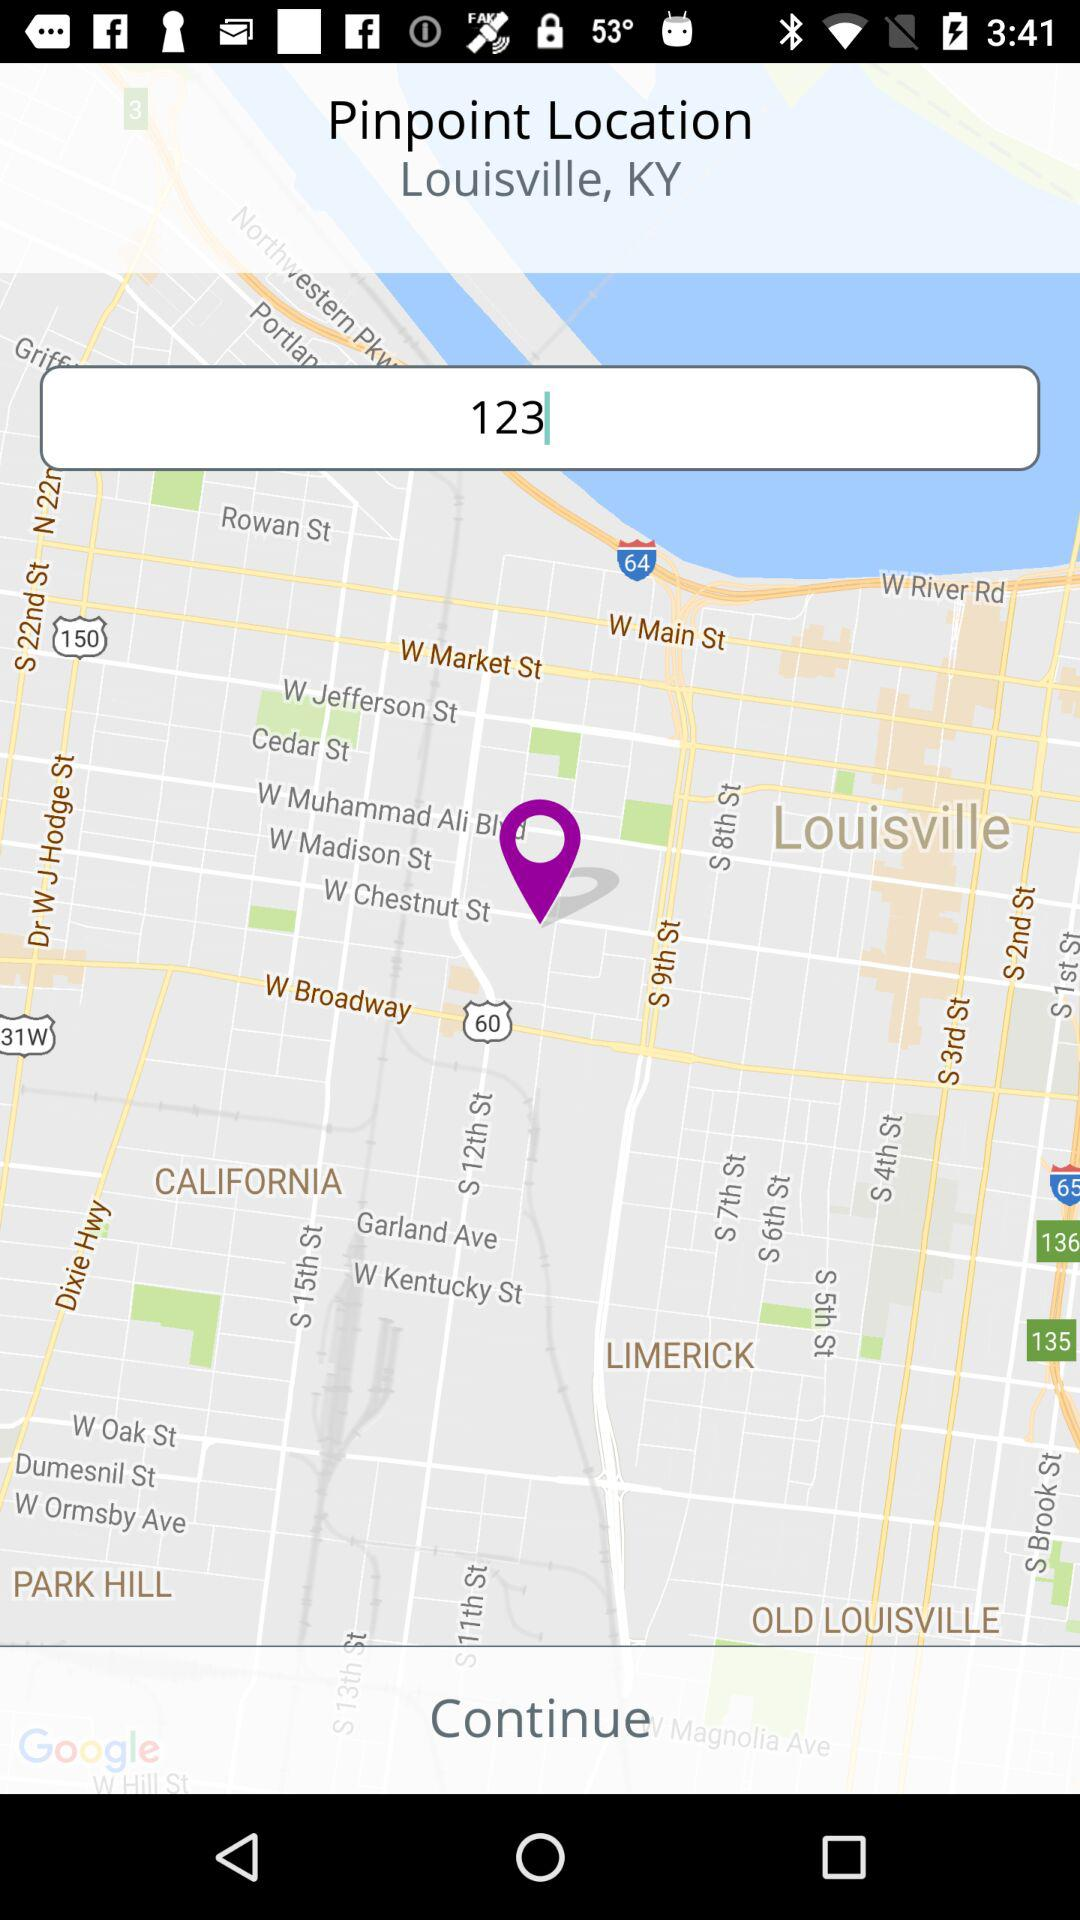What is the location? The location is Louisville, KY. 